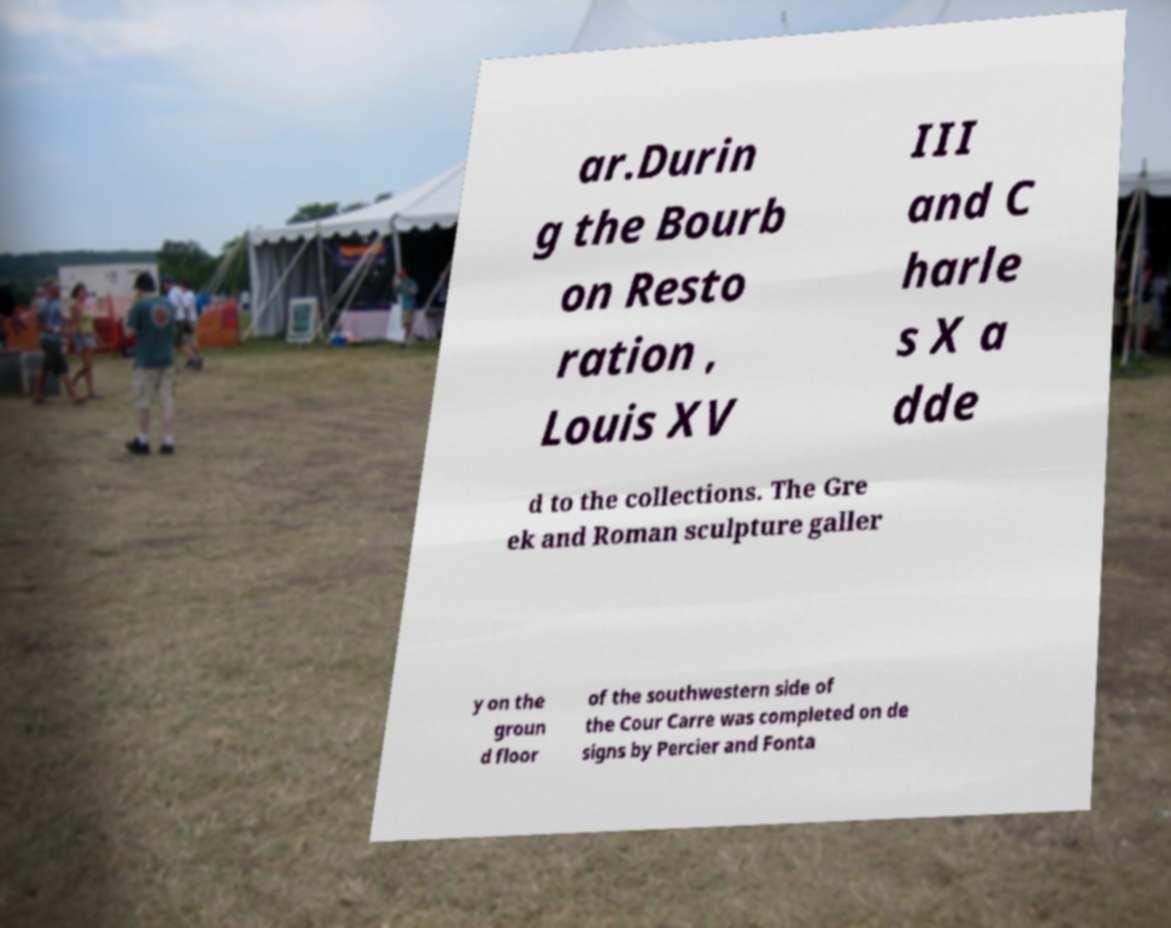Please identify and transcribe the text found in this image. ar.Durin g the Bourb on Resto ration , Louis XV III and C harle s X a dde d to the collections. The Gre ek and Roman sculpture galler y on the groun d floor of the southwestern side of the Cour Carre was completed on de signs by Percier and Fonta 